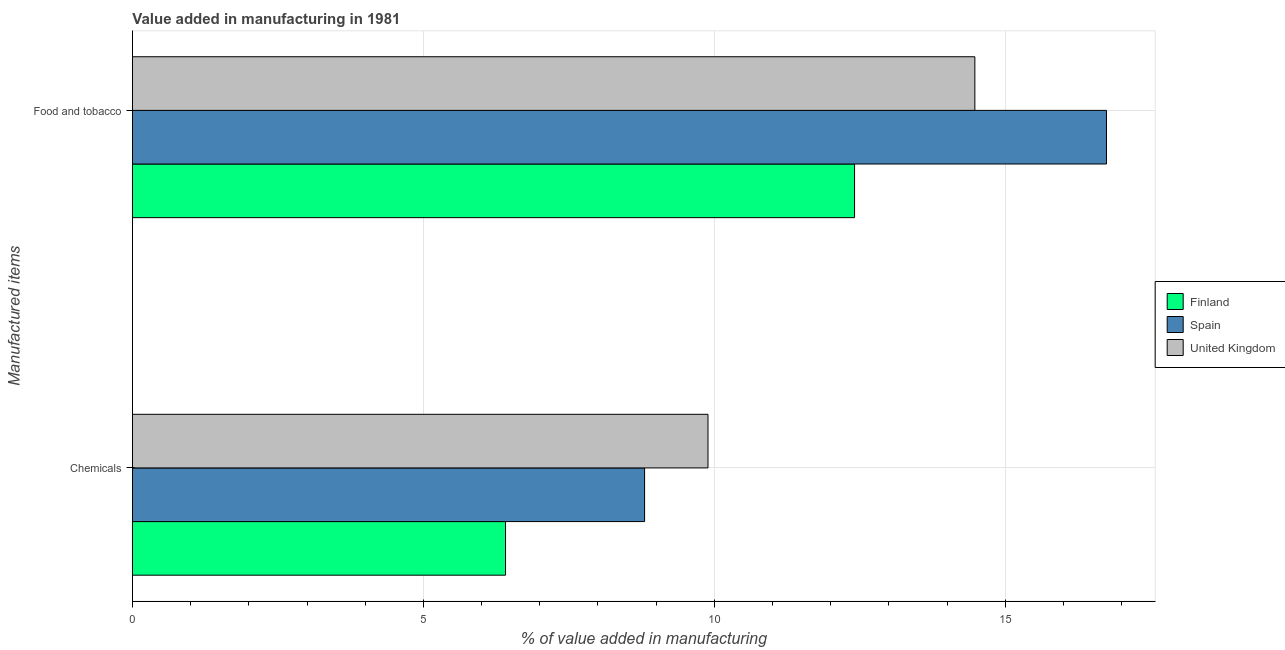How many different coloured bars are there?
Give a very brief answer. 3. What is the label of the 1st group of bars from the top?
Your response must be concise. Food and tobacco. What is the value added by  manufacturing chemicals in United Kingdom?
Offer a very short reply. 9.89. Across all countries, what is the maximum value added by manufacturing food and tobacco?
Give a very brief answer. 16.74. Across all countries, what is the minimum value added by manufacturing food and tobacco?
Your answer should be very brief. 12.41. In which country was the value added by manufacturing food and tobacco minimum?
Your answer should be very brief. Finland. What is the total value added by manufacturing food and tobacco in the graph?
Your response must be concise. 43.63. What is the difference between the value added by  manufacturing chemicals in Finland and that in Spain?
Your answer should be very brief. -2.39. What is the difference between the value added by manufacturing food and tobacco in United Kingdom and the value added by  manufacturing chemicals in Finland?
Give a very brief answer. 8.07. What is the average value added by manufacturing food and tobacco per country?
Offer a very short reply. 14.54. What is the difference between the value added by  manufacturing chemicals and value added by manufacturing food and tobacco in United Kingdom?
Offer a very short reply. -4.59. In how many countries, is the value added by  manufacturing chemicals greater than 15 %?
Keep it short and to the point. 0. What is the ratio of the value added by manufacturing food and tobacco in United Kingdom to that in Finland?
Your answer should be compact. 1.17. Is the value added by manufacturing food and tobacco in Spain less than that in United Kingdom?
Ensure brevity in your answer.  No. What does the 3rd bar from the top in Chemicals represents?
Make the answer very short. Finland. What does the 3rd bar from the bottom in Chemicals represents?
Ensure brevity in your answer.  United Kingdom. How many bars are there?
Offer a very short reply. 6. How many countries are there in the graph?
Keep it short and to the point. 3. What is the difference between two consecutive major ticks on the X-axis?
Make the answer very short. 5. Does the graph contain any zero values?
Offer a terse response. No. How are the legend labels stacked?
Keep it short and to the point. Vertical. What is the title of the graph?
Keep it short and to the point. Value added in manufacturing in 1981. Does "New Zealand" appear as one of the legend labels in the graph?
Provide a succinct answer. No. What is the label or title of the X-axis?
Provide a short and direct response. % of value added in manufacturing. What is the label or title of the Y-axis?
Keep it short and to the point. Manufactured items. What is the % of value added in manufacturing in Finland in Chemicals?
Provide a short and direct response. 6.41. What is the % of value added in manufacturing of Spain in Chemicals?
Ensure brevity in your answer.  8.8. What is the % of value added in manufacturing in United Kingdom in Chemicals?
Provide a succinct answer. 9.89. What is the % of value added in manufacturing of Finland in Food and tobacco?
Ensure brevity in your answer.  12.41. What is the % of value added in manufacturing of Spain in Food and tobacco?
Your answer should be compact. 16.74. What is the % of value added in manufacturing in United Kingdom in Food and tobacco?
Provide a succinct answer. 14.48. Across all Manufactured items, what is the maximum % of value added in manufacturing in Finland?
Your response must be concise. 12.41. Across all Manufactured items, what is the maximum % of value added in manufacturing in Spain?
Offer a terse response. 16.74. Across all Manufactured items, what is the maximum % of value added in manufacturing of United Kingdom?
Keep it short and to the point. 14.48. Across all Manufactured items, what is the minimum % of value added in manufacturing of Finland?
Make the answer very short. 6.41. Across all Manufactured items, what is the minimum % of value added in manufacturing in Spain?
Provide a succinct answer. 8.8. Across all Manufactured items, what is the minimum % of value added in manufacturing in United Kingdom?
Provide a succinct answer. 9.89. What is the total % of value added in manufacturing of Finland in the graph?
Make the answer very short. 18.82. What is the total % of value added in manufacturing in Spain in the graph?
Offer a very short reply. 25.54. What is the total % of value added in manufacturing in United Kingdom in the graph?
Offer a very short reply. 24.37. What is the difference between the % of value added in manufacturing of Finland in Chemicals and that in Food and tobacco?
Provide a short and direct response. -6. What is the difference between the % of value added in manufacturing of Spain in Chemicals and that in Food and tobacco?
Provide a succinct answer. -7.94. What is the difference between the % of value added in manufacturing of United Kingdom in Chemicals and that in Food and tobacco?
Your answer should be compact. -4.59. What is the difference between the % of value added in manufacturing in Finland in Chemicals and the % of value added in manufacturing in Spain in Food and tobacco?
Make the answer very short. -10.33. What is the difference between the % of value added in manufacturing in Finland in Chemicals and the % of value added in manufacturing in United Kingdom in Food and tobacco?
Give a very brief answer. -8.07. What is the difference between the % of value added in manufacturing in Spain in Chemicals and the % of value added in manufacturing in United Kingdom in Food and tobacco?
Provide a short and direct response. -5.68. What is the average % of value added in manufacturing in Finland per Manufactured items?
Provide a succinct answer. 9.41. What is the average % of value added in manufacturing in Spain per Manufactured items?
Ensure brevity in your answer.  12.77. What is the average % of value added in manufacturing in United Kingdom per Manufactured items?
Keep it short and to the point. 12.18. What is the difference between the % of value added in manufacturing of Finland and % of value added in manufacturing of Spain in Chemicals?
Ensure brevity in your answer.  -2.39. What is the difference between the % of value added in manufacturing in Finland and % of value added in manufacturing in United Kingdom in Chemicals?
Make the answer very short. -3.48. What is the difference between the % of value added in manufacturing in Spain and % of value added in manufacturing in United Kingdom in Chemicals?
Provide a succinct answer. -1.09. What is the difference between the % of value added in manufacturing of Finland and % of value added in manufacturing of Spain in Food and tobacco?
Provide a succinct answer. -4.33. What is the difference between the % of value added in manufacturing of Finland and % of value added in manufacturing of United Kingdom in Food and tobacco?
Provide a succinct answer. -2.07. What is the difference between the % of value added in manufacturing of Spain and % of value added in manufacturing of United Kingdom in Food and tobacco?
Your answer should be very brief. 2.26. What is the ratio of the % of value added in manufacturing in Finland in Chemicals to that in Food and tobacco?
Provide a short and direct response. 0.52. What is the ratio of the % of value added in manufacturing of Spain in Chemicals to that in Food and tobacco?
Your answer should be very brief. 0.53. What is the ratio of the % of value added in manufacturing in United Kingdom in Chemicals to that in Food and tobacco?
Your response must be concise. 0.68. What is the difference between the highest and the second highest % of value added in manufacturing in Finland?
Provide a short and direct response. 6. What is the difference between the highest and the second highest % of value added in manufacturing in Spain?
Offer a very short reply. 7.94. What is the difference between the highest and the second highest % of value added in manufacturing of United Kingdom?
Provide a succinct answer. 4.59. What is the difference between the highest and the lowest % of value added in manufacturing in Finland?
Provide a succinct answer. 6. What is the difference between the highest and the lowest % of value added in manufacturing in Spain?
Ensure brevity in your answer.  7.94. What is the difference between the highest and the lowest % of value added in manufacturing of United Kingdom?
Give a very brief answer. 4.59. 